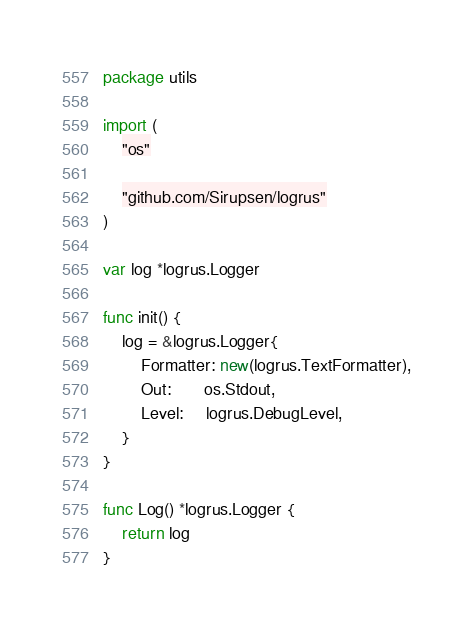Convert code to text. <code><loc_0><loc_0><loc_500><loc_500><_Go_>package utils

import (
	"os"

	"github.com/Sirupsen/logrus"
)

var log *logrus.Logger

func init() {
	log = &logrus.Logger{
		Formatter: new(logrus.TextFormatter),
		Out:       os.Stdout,
		Level:     logrus.DebugLevel,
	}
}

func Log() *logrus.Logger {
	return log
}</code> 